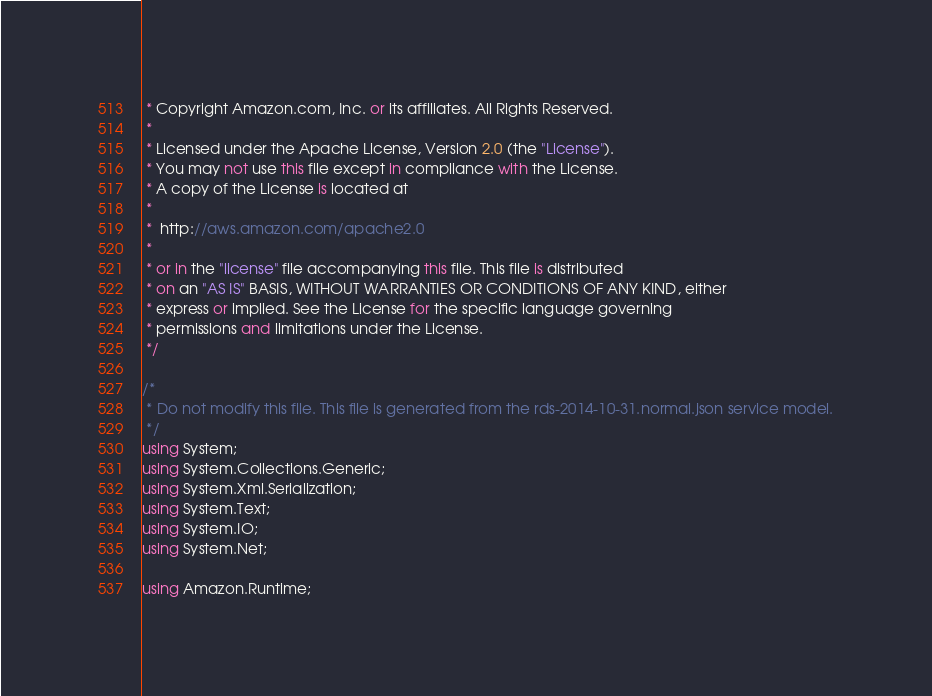<code> <loc_0><loc_0><loc_500><loc_500><_C#_> * Copyright Amazon.com, Inc. or its affiliates. All Rights Reserved.
 * 
 * Licensed under the Apache License, Version 2.0 (the "License").
 * You may not use this file except in compliance with the License.
 * A copy of the License is located at
 * 
 *  http://aws.amazon.com/apache2.0
 * 
 * or in the "license" file accompanying this file. This file is distributed
 * on an "AS IS" BASIS, WITHOUT WARRANTIES OR CONDITIONS OF ANY KIND, either
 * express or implied. See the License for the specific language governing
 * permissions and limitations under the License.
 */

/*
 * Do not modify this file. This file is generated from the rds-2014-10-31.normal.json service model.
 */
using System;
using System.Collections.Generic;
using System.Xml.Serialization;
using System.Text;
using System.IO;
using System.Net;

using Amazon.Runtime;</code> 